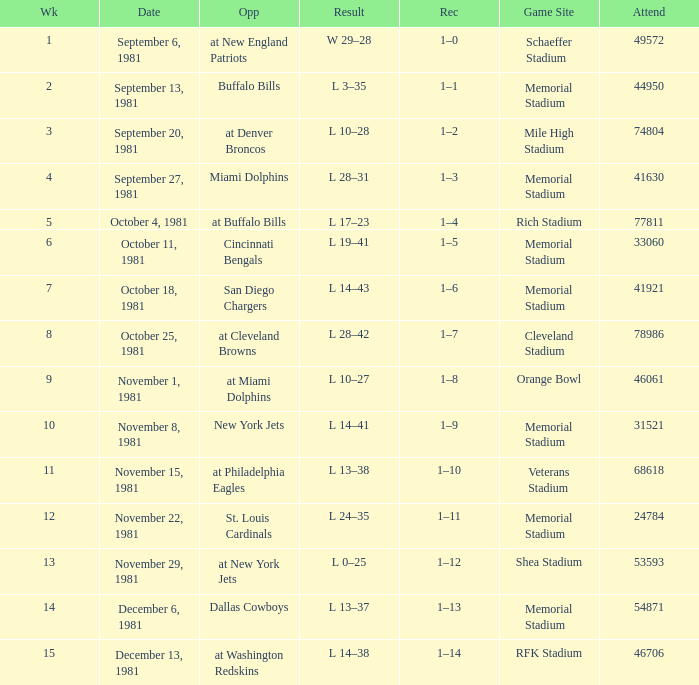When 74804 is the attendance what week is it? 3.0. 